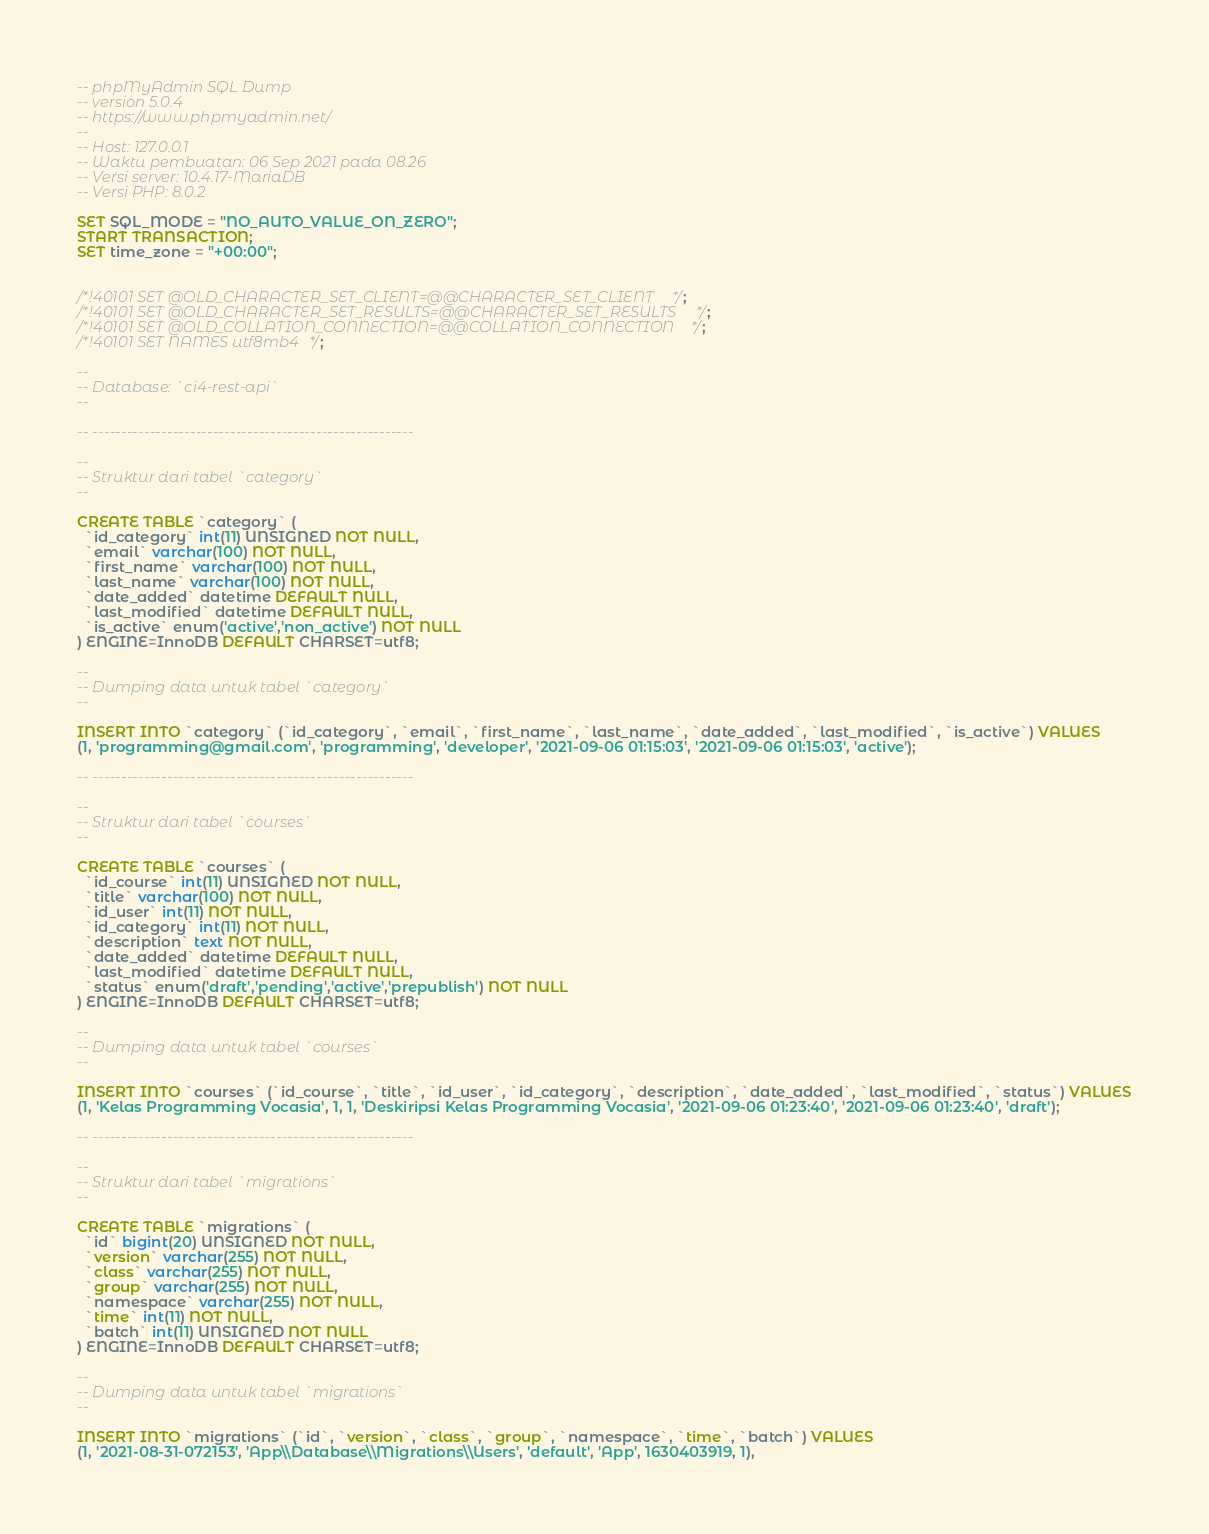Convert code to text. <code><loc_0><loc_0><loc_500><loc_500><_SQL_>-- phpMyAdmin SQL Dump
-- version 5.0.4
-- https://www.phpmyadmin.net/
--
-- Host: 127.0.0.1
-- Waktu pembuatan: 06 Sep 2021 pada 08.26
-- Versi server: 10.4.17-MariaDB
-- Versi PHP: 8.0.2

SET SQL_MODE = "NO_AUTO_VALUE_ON_ZERO";
START TRANSACTION;
SET time_zone = "+00:00";


/*!40101 SET @OLD_CHARACTER_SET_CLIENT=@@CHARACTER_SET_CLIENT */;
/*!40101 SET @OLD_CHARACTER_SET_RESULTS=@@CHARACTER_SET_RESULTS */;
/*!40101 SET @OLD_COLLATION_CONNECTION=@@COLLATION_CONNECTION */;
/*!40101 SET NAMES utf8mb4 */;

--
-- Database: `ci4-rest-api`
--

-- --------------------------------------------------------

--
-- Struktur dari tabel `category`
--

CREATE TABLE `category` (
  `id_category` int(11) UNSIGNED NOT NULL,
  `email` varchar(100) NOT NULL,
  `first_name` varchar(100) NOT NULL,
  `last_name` varchar(100) NOT NULL,
  `date_added` datetime DEFAULT NULL,
  `last_modified` datetime DEFAULT NULL,
  `is_active` enum('active','non_active') NOT NULL
) ENGINE=InnoDB DEFAULT CHARSET=utf8;

--
-- Dumping data untuk tabel `category`
--

INSERT INTO `category` (`id_category`, `email`, `first_name`, `last_name`, `date_added`, `last_modified`, `is_active`) VALUES
(1, 'programming@gmail.com', 'programming', 'developer', '2021-09-06 01:15:03', '2021-09-06 01:15:03', 'active');

-- --------------------------------------------------------

--
-- Struktur dari tabel `courses`
--

CREATE TABLE `courses` (
  `id_course` int(11) UNSIGNED NOT NULL,
  `title` varchar(100) NOT NULL,
  `id_user` int(11) NOT NULL,
  `id_category` int(11) NOT NULL,
  `description` text NOT NULL,
  `date_added` datetime DEFAULT NULL,
  `last_modified` datetime DEFAULT NULL,
  `status` enum('draft','pending','active','prepublish') NOT NULL
) ENGINE=InnoDB DEFAULT CHARSET=utf8;

--
-- Dumping data untuk tabel `courses`
--

INSERT INTO `courses` (`id_course`, `title`, `id_user`, `id_category`, `description`, `date_added`, `last_modified`, `status`) VALUES
(1, 'Kelas Programming Vocasia', 1, 1, 'Deskiripsi Kelas Programming Vocasia', '2021-09-06 01:23:40', '2021-09-06 01:23:40', 'draft');

-- --------------------------------------------------------

--
-- Struktur dari tabel `migrations`
--

CREATE TABLE `migrations` (
  `id` bigint(20) UNSIGNED NOT NULL,
  `version` varchar(255) NOT NULL,
  `class` varchar(255) NOT NULL,
  `group` varchar(255) NOT NULL,
  `namespace` varchar(255) NOT NULL,
  `time` int(11) NOT NULL,
  `batch` int(11) UNSIGNED NOT NULL
) ENGINE=InnoDB DEFAULT CHARSET=utf8;

--
-- Dumping data untuk tabel `migrations`
--

INSERT INTO `migrations` (`id`, `version`, `class`, `group`, `namespace`, `time`, `batch`) VALUES
(1, '2021-08-31-072153', 'App\\Database\\Migrations\\Users', 'default', 'App', 1630403919, 1),</code> 